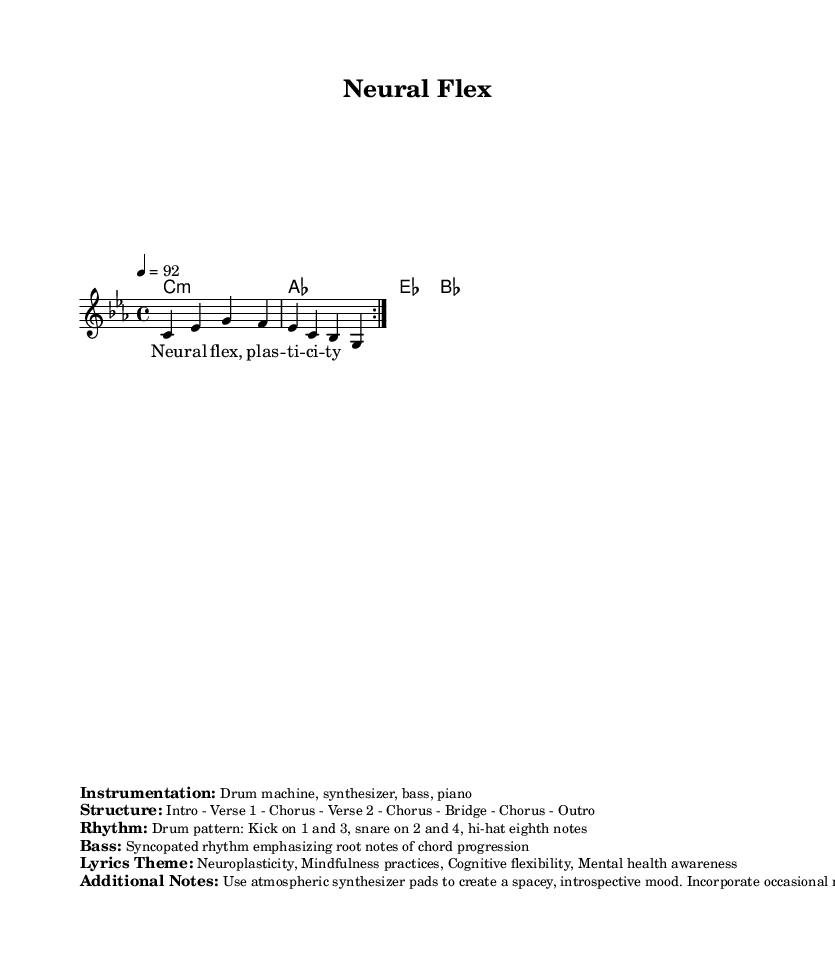What is the key signature of this music? The key signature is indicated at the beginning of the score and shows one flat, which is characteristic of C minor.
Answer: C minor What is the time signature of this score? The time signature is located after the key signature at the beginning of the score, which is 4/4. This indicates that there are four beats in each measure.
Answer: 4/4 What is the tempo marking provided in the music? The tempo marking is found within the global section at the beginning of the score and indicates how fast the music should be played. It is marked as quarter note equals 92 beats per minute.
Answer: 92 How many verses are there in the structure of this piece? The structure listed in the markup section provides the layout of the music. It shows that there are two verses.
Answer: 2 What theme do the lyrics of this piece focus on? The lyrics theme is specified in the markup section and summarizes the main concepts of the song. The focus is on topics related to neuroplasticity and mindfulness practices.
Answer: Neuroplasticity, Mindfulness practices Which instruments are indicated for use in the composition? The instrumentation details are mentioned in the markup section, which outlines the specific instruments to be used in performing the piece. This includes a drum machine, synthesizer, bass, and piano.
Answer: Drum machine, synthesizer, bass, piano What type of rhythm is emphasized in the bass line? The rhythm for the bass is found in the markup section and highlights the characteristic style of the bass line in hip-hop, which is syncopated and emphasizes the root notes of the chord progression.
Answer: Syncopated rhythm 